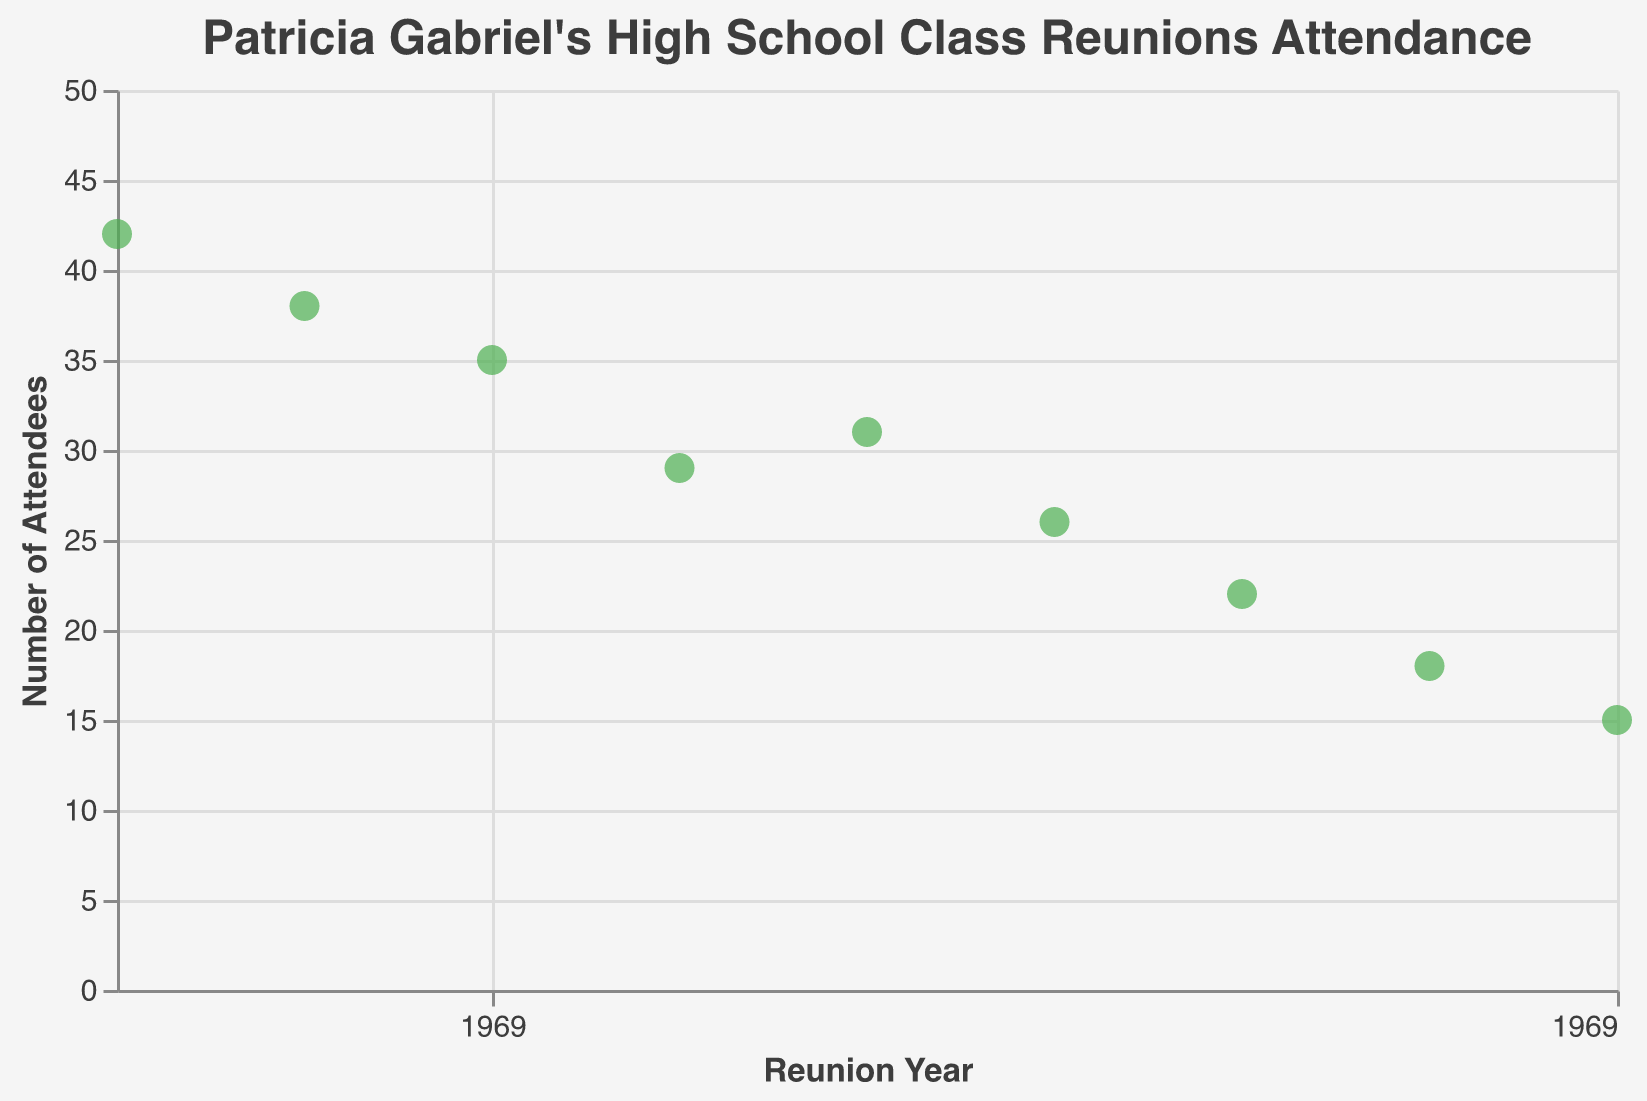How many reunion attendance data points are plotted? Each point on the strip plot represents a data entry. By counting the points, we see that there are 9 data points.
Answer: 9 What is the highest attendance recorded? By observing the y-axis and the position of the points on the plot, the highest point is at 42 attendees in the year 1985.
Answer: 42 What is the trend in reunion attendance over the years? By examining the direction of the points from 1985 to 2025, the overall trend shows a decline in attendance over the years.
Answer: Decline How many years show an attendance below 30? Points below the 30 mark on the y-axis correspond to the years 2000, 2005, 2010, 2015, 2020, and 2025. So there are 6 years with attendance below 30.
Answer: 6 Compare the attendance between the years 2010 and 2015. Which year had higher attendance? Both years' points are examined; the point for 2010 is at 26, and for 2015, it is at 22. Therefore, the year 2010 had higher attendance.
Answer: 2010 What is the change in attendance from the first year plotted (1985) to the last year plotted (2025)? Subtract the attendance in 2025 (15) from the attendance in 1985 (42). The change is 42 - 15 = 27.
Answer: 27 What is the average attendance over all the years plotted? Sum all the attendance numbers and divide by the number of data points. (42+38+35+29+31+26+22+18+15) / 9 = 28.4.
Answer: 28.4 Which year had an attendance exactly halfway between the highest (42) and lowest (15) values? The midpoint between 42 and 15 is (42 + 15) / 2 = 28.5. The year closest to 28.5 in attendance is 2000 with 29 attendees.
Answer: 2000 What is the median attendance value for the plotted years? Arrange the attendance values in ascending order: 15, 18, 22, 26, 29, 31, 35, 38, 42. The middle value is 29, as it is the 5th number in the 9 entries.
Answer: 29 